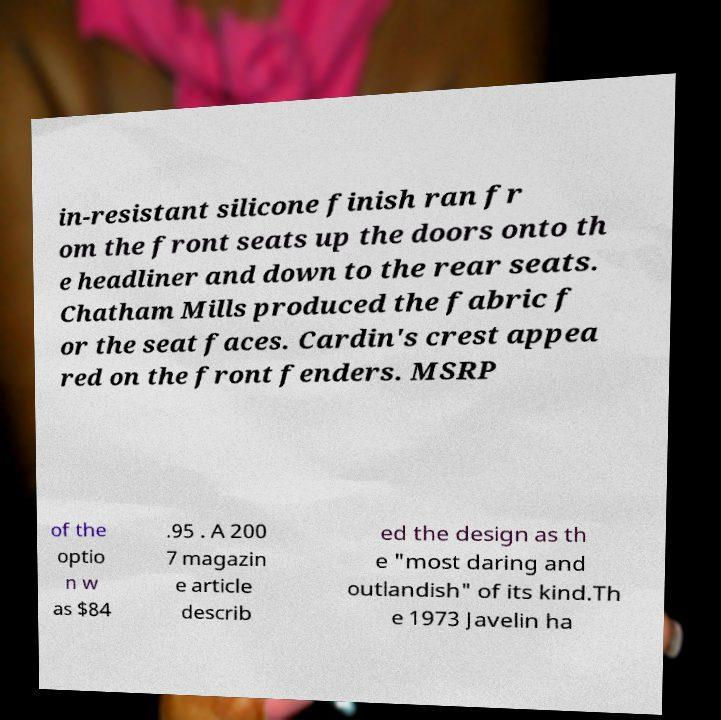Could you assist in decoding the text presented in this image and type it out clearly? in-resistant silicone finish ran fr om the front seats up the doors onto th e headliner and down to the rear seats. Chatham Mills produced the fabric f or the seat faces. Cardin's crest appea red on the front fenders. MSRP of the optio n w as $84 .95 . A 200 7 magazin e article describ ed the design as th e "most daring and outlandish" of its kind.Th e 1973 Javelin ha 